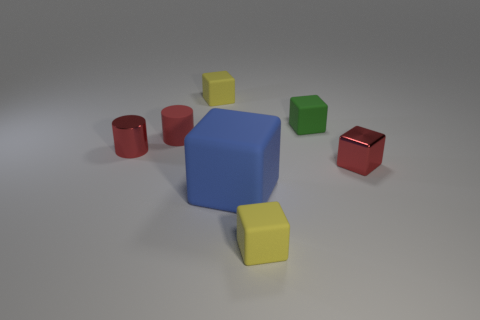Subtract all yellow blocks. How many were subtracted if there are1yellow blocks left? 1 Subtract all blue cubes. How many cubes are left? 4 Subtract all red cubes. How many cubes are left? 4 Subtract all blue blocks. Subtract all cyan balls. How many blocks are left? 4 Add 3 metal objects. How many objects exist? 10 Subtract all cubes. How many objects are left? 2 Add 1 red matte cylinders. How many red matte cylinders exist? 2 Subtract 0 yellow spheres. How many objects are left? 7 Subtract all big cubes. Subtract all small shiny cylinders. How many objects are left? 5 Add 2 tiny red shiny cylinders. How many tiny red shiny cylinders are left? 3 